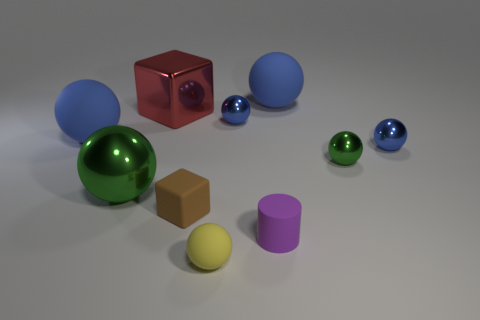Subtract all shiny spheres. How many spheres are left? 3 Subtract all yellow spheres. How many spheres are left? 6 Subtract all balls. How many objects are left? 3 Subtract 1 cylinders. How many cylinders are left? 0 Subtract all green cylinders. Subtract all cyan spheres. How many cylinders are left? 1 Subtract all purple cubes. How many yellow balls are left? 1 Subtract all tiny metal things. Subtract all yellow balls. How many objects are left? 6 Add 3 small blue objects. How many small blue objects are left? 5 Add 4 small brown metal objects. How many small brown metal objects exist? 4 Subtract 0 cyan balls. How many objects are left? 10 